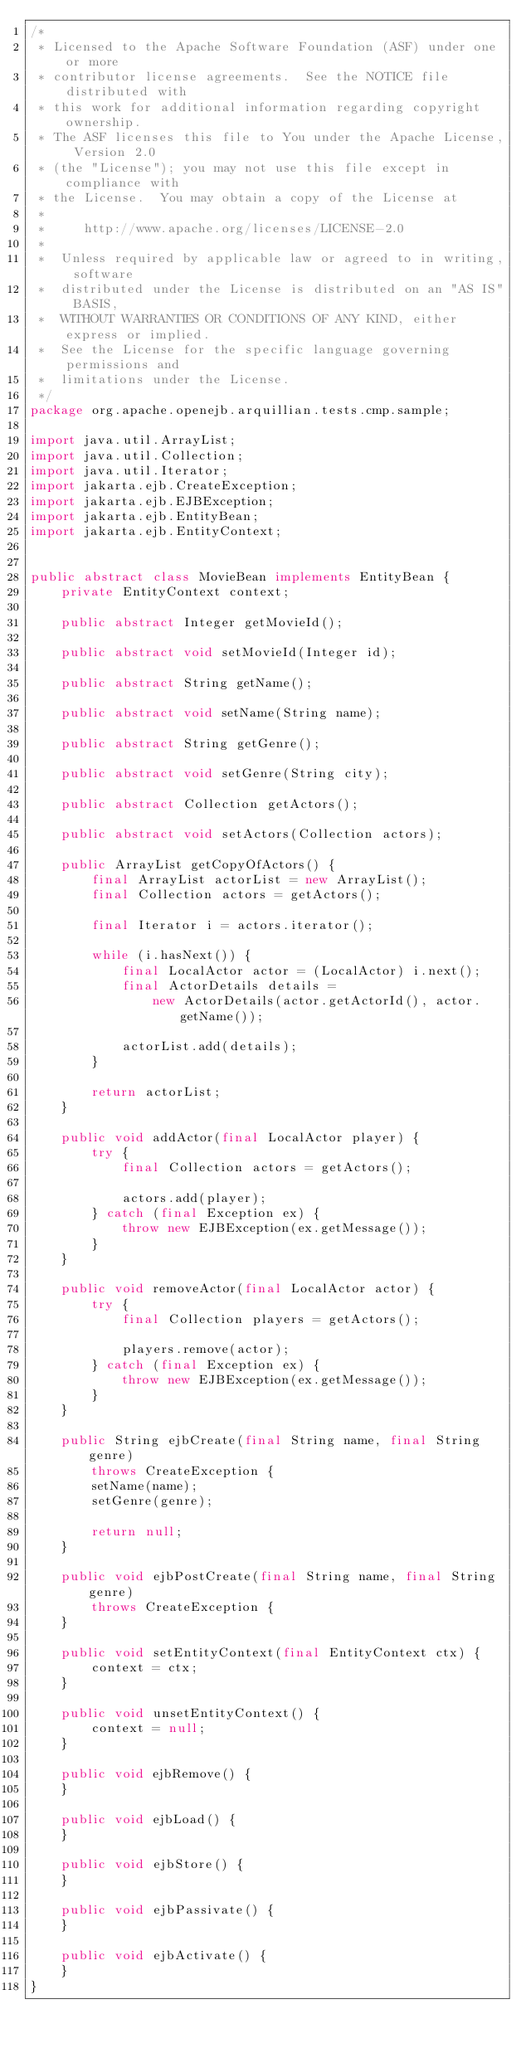<code> <loc_0><loc_0><loc_500><loc_500><_Java_>/*
 * Licensed to the Apache Software Foundation (ASF) under one or more
 * contributor license agreements.  See the NOTICE file distributed with
 * this work for additional information regarding copyright ownership.
 * The ASF licenses this file to You under the Apache License, Version 2.0
 * (the "License"); you may not use this file except in compliance with
 * the License.  You may obtain a copy of the License at
 *
 *     http://www.apache.org/licenses/LICENSE-2.0
 *
 *  Unless required by applicable law or agreed to in writing, software
 *  distributed under the License is distributed on an "AS IS" BASIS,
 *  WITHOUT WARRANTIES OR CONDITIONS OF ANY KIND, either express or implied.
 *  See the License for the specific language governing permissions and
 *  limitations under the License.
 */
package org.apache.openejb.arquillian.tests.cmp.sample;

import java.util.ArrayList;
import java.util.Collection;
import java.util.Iterator;
import jakarta.ejb.CreateException;
import jakarta.ejb.EJBException;
import jakarta.ejb.EntityBean;
import jakarta.ejb.EntityContext;


public abstract class MovieBean implements EntityBean {
    private EntityContext context;

    public abstract Integer getMovieId();

    public abstract void setMovieId(Integer id);

    public abstract String getName();

    public abstract void setName(String name);

    public abstract String getGenre();

    public abstract void setGenre(String city);

    public abstract Collection getActors();

    public abstract void setActors(Collection actors);

    public ArrayList getCopyOfActors() {
        final ArrayList actorList = new ArrayList();
        final Collection actors = getActors();

        final Iterator i = actors.iterator();

        while (i.hasNext()) {
            final LocalActor actor = (LocalActor) i.next();
            final ActorDetails details =
                new ActorDetails(actor.getActorId(), actor.getName());

            actorList.add(details);
        }

        return actorList;
    }

    public void addActor(final LocalActor player) {
        try {
            final Collection actors = getActors();

            actors.add(player);
        } catch (final Exception ex) {
            throw new EJBException(ex.getMessage());
        }
    }

    public void removeActor(final LocalActor actor) {
        try {
            final Collection players = getActors();

            players.remove(actor);
        } catch (final Exception ex) {
            throw new EJBException(ex.getMessage());
        }
    }

    public String ejbCreate(final String name, final String genre)
        throws CreateException {
        setName(name);
        setGenre(genre);

        return null;
    }

    public void ejbPostCreate(final String name, final String genre)
        throws CreateException {
    }

    public void setEntityContext(final EntityContext ctx) {
        context = ctx;
    }

    public void unsetEntityContext() {
        context = null;
    }

    public void ejbRemove() {
    }

    public void ejbLoad() {
    }

    public void ejbStore() {
    }

    public void ejbPassivate() {
    }

    public void ejbActivate() {
    }
}
</code> 